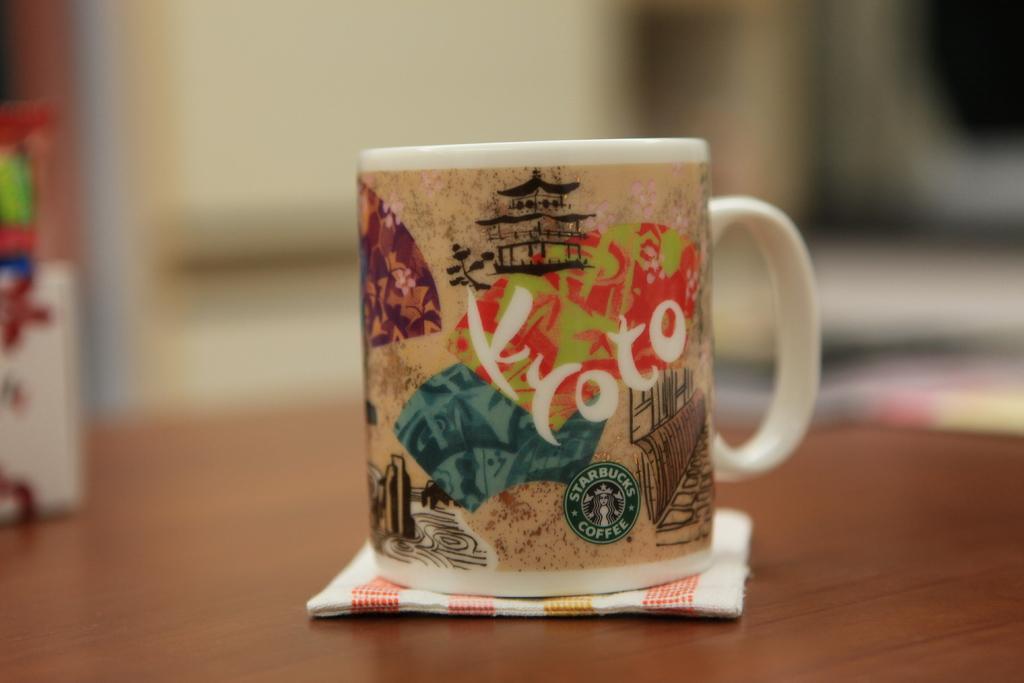Please provide a concise description of this image. Here I can see a table on which a mug is placed. Under the mug there is a napkin. On the left side there are three objects placed on the table. The background is blurred. 